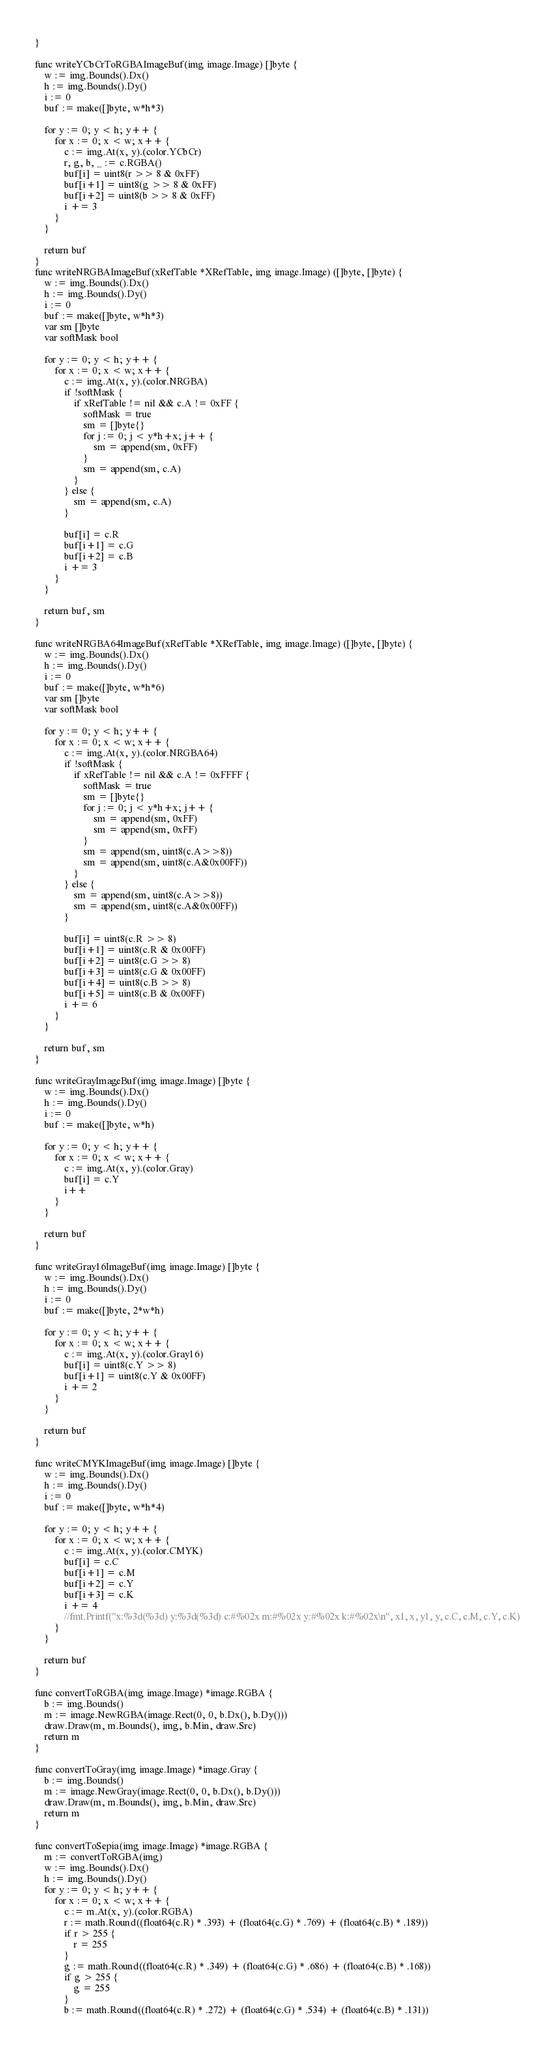Convert code to text. <code><loc_0><loc_0><loc_500><loc_500><_Go_>}

func writeYCbCrToRGBAImageBuf(img image.Image) []byte {
	w := img.Bounds().Dx()
	h := img.Bounds().Dy()
	i := 0
	buf := make([]byte, w*h*3)

	for y := 0; y < h; y++ {
		for x := 0; x < w; x++ {
			c := img.At(x, y).(color.YCbCr)
			r, g, b, _ := c.RGBA()
			buf[i] = uint8(r >> 8 & 0xFF)
			buf[i+1] = uint8(g >> 8 & 0xFF)
			buf[i+2] = uint8(b >> 8 & 0xFF)
			i += 3
		}
	}

	return buf
}
func writeNRGBAImageBuf(xRefTable *XRefTable, img image.Image) ([]byte, []byte) {
	w := img.Bounds().Dx()
	h := img.Bounds().Dy()
	i := 0
	buf := make([]byte, w*h*3)
	var sm []byte
	var softMask bool

	for y := 0; y < h; y++ {
		for x := 0; x < w; x++ {
			c := img.At(x, y).(color.NRGBA)
			if !softMask {
				if xRefTable != nil && c.A != 0xFF {
					softMask = true
					sm = []byte{}
					for j := 0; j < y*h+x; j++ {
						sm = append(sm, 0xFF)
					}
					sm = append(sm, c.A)
				}
			} else {
				sm = append(sm, c.A)
			}

			buf[i] = c.R
			buf[i+1] = c.G
			buf[i+2] = c.B
			i += 3
		}
	}

	return buf, sm
}

func writeNRGBA64ImageBuf(xRefTable *XRefTable, img image.Image) ([]byte, []byte) {
	w := img.Bounds().Dx()
	h := img.Bounds().Dy()
	i := 0
	buf := make([]byte, w*h*6)
	var sm []byte
	var softMask bool

	for y := 0; y < h; y++ {
		for x := 0; x < w; x++ {
			c := img.At(x, y).(color.NRGBA64)
			if !softMask {
				if xRefTable != nil && c.A != 0xFFFF {
					softMask = true
					sm = []byte{}
					for j := 0; j < y*h+x; j++ {
						sm = append(sm, 0xFF)
						sm = append(sm, 0xFF)
					}
					sm = append(sm, uint8(c.A>>8))
					sm = append(sm, uint8(c.A&0x00FF))
				}
			} else {
				sm = append(sm, uint8(c.A>>8))
				sm = append(sm, uint8(c.A&0x00FF))
			}

			buf[i] = uint8(c.R >> 8)
			buf[i+1] = uint8(c.R & 0x00FF)
			buf[i+2] = uint8(c.G >> 8)
			buf[i+3] = uint8(c.G & 0x00FF)
			buf[i+4] = uint8(c.B >> 8)
			buf[i+5] = uint8(c.B & 0x00FF)
			i += 6
		}
	}

	return buf, sm
}

func writeGrayImageBuf(img image.Image) []byte {
	w := img.Bounds().Dx()
	h := img.Bounds().Dy()
	i := 0
	buf := make([]byte, w*h)

	for y := 0; y < h; y++ {
		for x := 0; x < w; x++ {
			c := img.At(x, y).(color.Gray)
			buf[i] = c.Y
			i++
		}
	}

	return buf
}

func writeGray16ImageBuf(img image.Image) []byte {
	w := img.Bounds().Dx()
	h := img.Bounds().Dy()
	i := 0
	buf := make([]byte, 2*w*h)

	for y := 0; y < h; y++ {
		for x := 0; x < w; x++ {
			c := img.At(x, y).(color.Gray16)
			buf[i] = uint8(c.Y >> 8)
			buf[i+1] = uint8(c.Y & 0x00FF)
			i += 2
		}
	}

	return buf
}

func writeCMYKImageBuf(img image.Image) []byte {
	w := img.Bounds().Dx()
	h := img.Bounds().Dy()
	i := 0
	buf := make([]byte, w*h*4)

	for y := 0; y < h; y++ {
		for x := 0; x < w; x++ {
			c := img.At(x, y).(color.CMYK)
			buf[i] = c.C
			buf[i+1] = c.M
			buf[i+2] = c.Y
			buf[i+3] = c.K
			i += 4
			//fmt.Printf("x:%3d(%3d) y:%3d(%3d) c:#%02x m:#%02x y:#%02x k:#%02x\n", x1, x, y1, y, c.C, c.M, c.Y, c.K)
		}
	}

	return buf
}

func convertToRGBA(img image.Image) *image.RGBA {
	b := img.Bounds()
	m := image.NewRGBA(image.Rect(0, 0, b.Dx(), b.Dy()))
	draw.Draw(m, m.Bounds(), img, b.Min, draw.Src)
	return m
}

func convertToGray(img image.Image) *image.Gray {
	b := img.Bounds()
	m := image.NewGray(image.Rect(0, 0, b.Dx(), b.Dy()))
	draw.Draw(m, m.Bounds(), img, b.Min, draw.Src)
	return m
}

func convertToSepia(img image.Image) *image.RGBA {
	m := convertToRGBA(img)
	w := img.Bounds().Dx()
	h := img.Bounds().Dy()
	for y := 0; y < h; y++ {
		for x := 0; x < w; x++ {
			c := m.At(x, y).(color.RGBA)
			r := math.Round((float64(c.R) * .393) + (float64(c.G) * .769) + (float64(c.B) * .189))
			if r > 255 {
				r = 255
			}
			g := math.Round((float64(c.R) * .349) + (float64(c.G) * .686) + (float64(c.B) * .168))
			if g > 255 {
				g = 255
			}
			b := math.Round((float64(c.R) * .272) + (float64(c.G) * .534) + (float64(c.B) * .131))</code> 